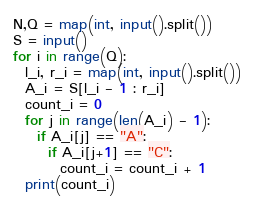Convert code to text. <code><loc_0><loc_0><loc_500><loc_500><_Python_>N,Q = map(int, input().split())
S = input()
for i in range(Q):
  l_i, r_i = map(int, input().split())
  A_i = S[l_i - 1 : r_i]
  count_i = 0
  for j in range(len(A_i) - 1):
    if A_i[j] == "A":
      if A_i[j+1] == "C":
        count_i = count_i + 1
  print(count_i)</code> 